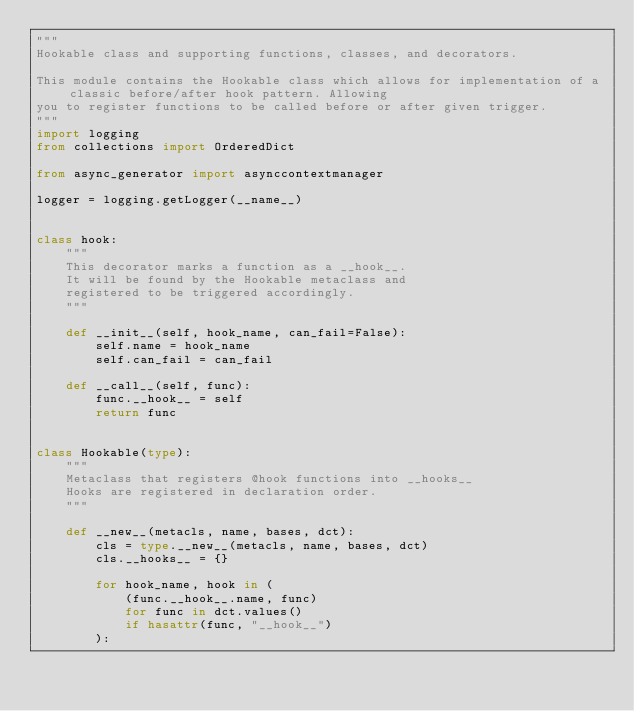<code> <loc_0><loc_0><loc_500><loc_500><_Python_>"""
Hookable class and supporting functions, classes, and decorators.

This module contains the Hookable class which allows for implementation of a classic before/after hook pattern. Allowing
you to register functions to be called before or after given trigger.
"""
import logging
from collections import OrderedDict

from async_generator import asynccontextmanager

logger = logging.getLogger(__name__)


class hook:
    """
    This decorator marks a function as a __hook__.
    It will be found by the Hookable metaclass and
    registered to be triggered accordingly.
    """

    def __init__(self, hook_name, can_fail=False):
        self.name = hook_name
        self.can_fail = can_fail

    def __call__(self, func):
        func.__hook__ = self
        return func


class Hookable(type):
    """
    Metaclass that registers @hook functions into __hooks__
    Hooks are registered in declaration order.
    """

    def __new__(metacls, name, bases, dct):
        cls = type.__new__(metacls, name, bases, dct)
        cls.__hooks__ = {}

        for hook_name, hook in (
            (func.__hook__.name, func)
            for func in dct.values()
            if hasattr(func, "__hook__")
        ):</code> 